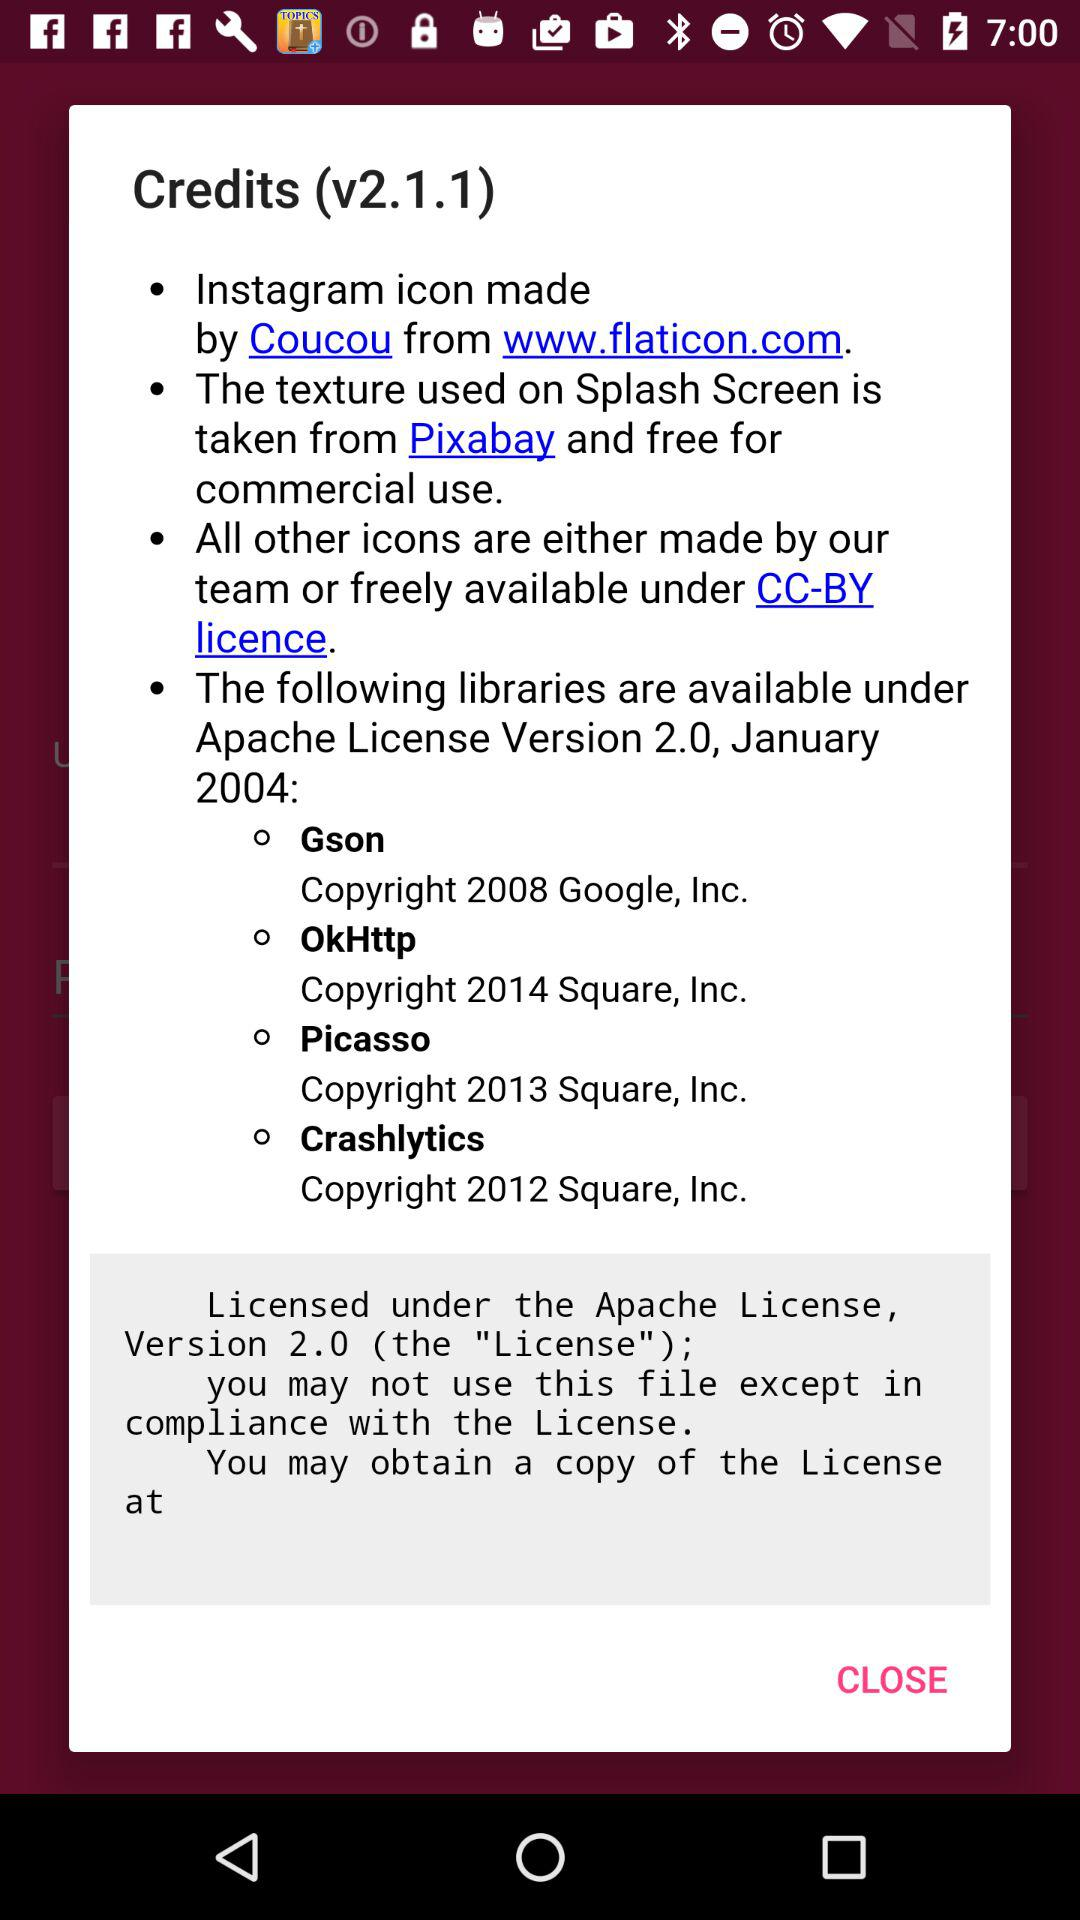Who made the "Instagram" icon? The "Instagram" icon was made by "Coucou". 